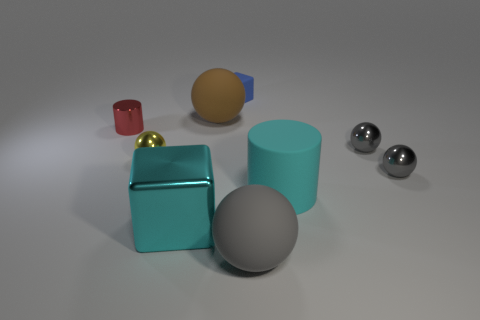Subtract all blue blocks. How many gray spheres are left? 3 Subtract all big brown rubber balls. How many balls are left? 4 Subtract all brown balls. How many balls are left? 4 Add 1 big metallic cubes. How many objects exist? 10 Subtract all cyan balls. Subtract all gray blocks. How many balls are left? 5 Subtract all big gray rubber balls. Subtract all tiny gray spheres. How many objects are left? 6 Add 8 big gray rubber spheres. How many big gray rubber spheres are left? 9 Add 6 small gray cylinders. How many small gray cylinders exist? 6 Subtract 0 purple spheres. How many objects are left? 9 Subtract all cylinders. How many objects are left? 7 